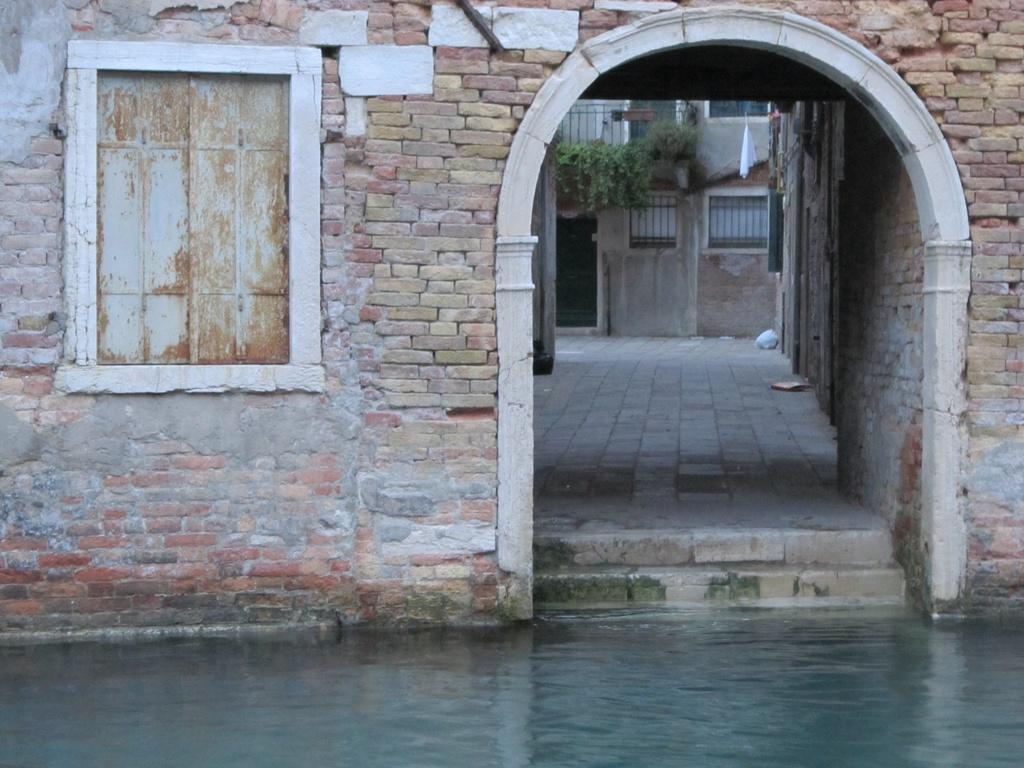What type of structure is present in the image? There is a building in the picture. What features can be seen on the building? The building has a door and a window. Can you describe the background of the image? There is another building in the background, and there is a balcony with plants. How many frogs are sitting on the window ledge in the image? There are no frogs present in the image. Can you see a cobweb in any corner of the building in the image? There is no mention of a cobweb in the image, so it cannot be determined if one is present. 